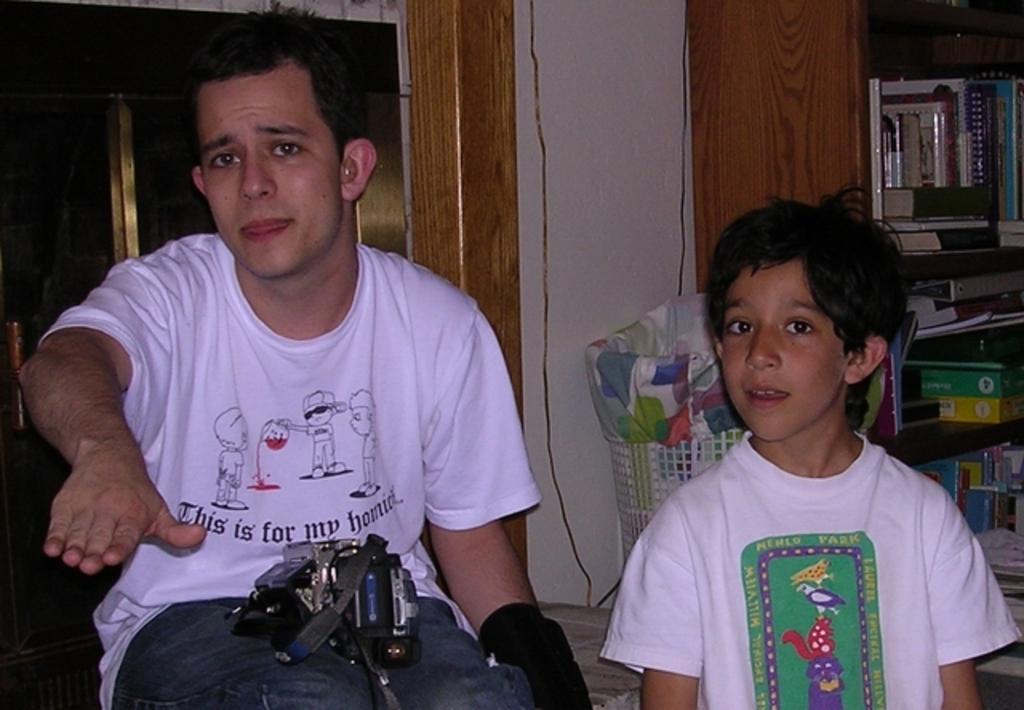In one or two sentences, can you explain what this image depicts? There is a man sitting and holding an object, beside this man there is a boy standing. In the background we can see basket, books and objects in racks and wall. 